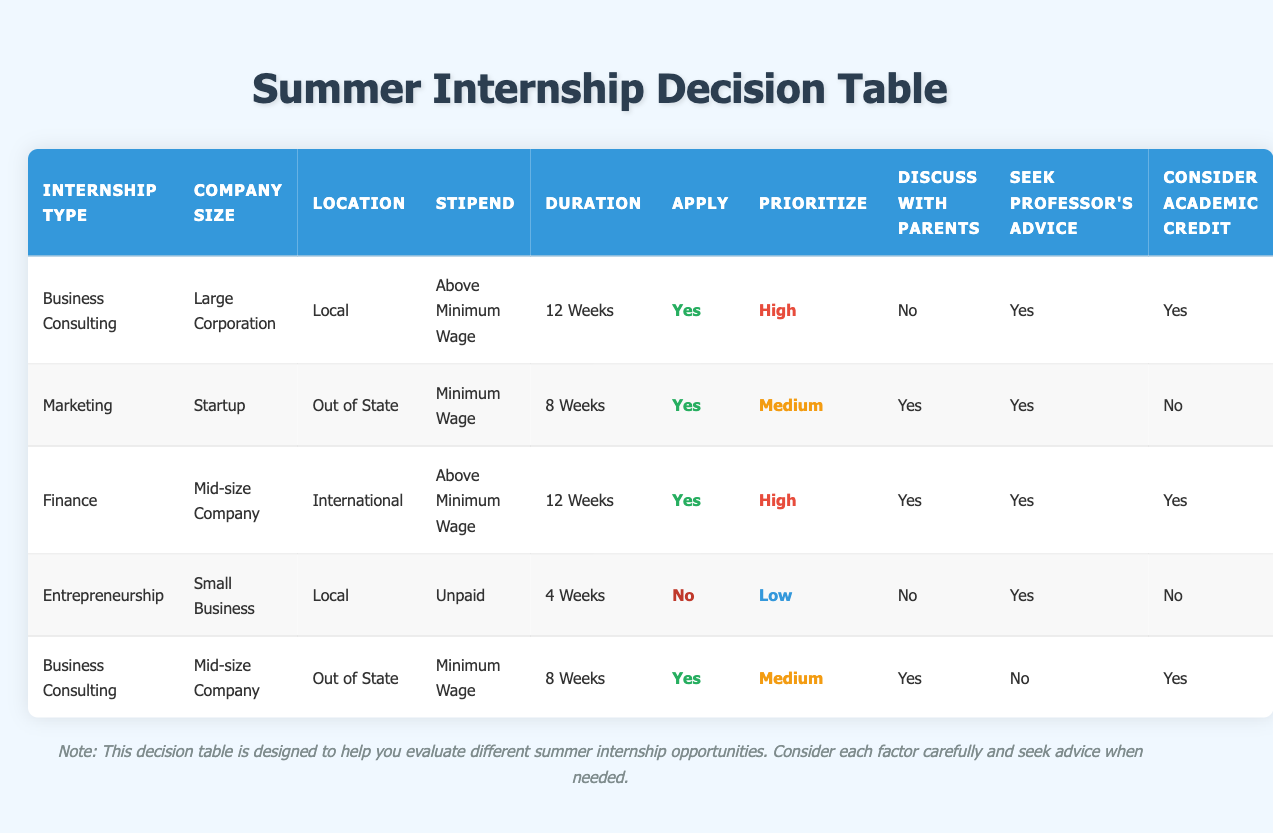What internship type has the highest priority level? The table shows various internship types along with their priority levels. By scanning through the "Prioritize" column, I can identify that both "Business Consulting" at "Large Corporation" and "Finance" at "Mid-size Company" have a priority level of "High." Since "High" is the highest priority, both these internship types qualify.
Answer: Business Consulting, Finance Is there any internship that has an unpaid stipend? Looking at the "Stipend" column, I find that the "Entrepreneurship" internship at "Small Business" has a stipend categorized as "Unpaid." It is confirmed by directly referencing the value in that column.
Answer: Yes How many internships last for 8 weeks? I can count the total number of internships in the "Duration" column that specifically states "8 Weeks." Upon reviewing the table, both the "Marketing" internship and the "Business Consulting" internship (Mid-size Company) last for 8 weeks. This gives a total of two internships.
Answer: 2 For which internship types should I discuss the opportunities with my parents? I need to check the "Discuss with Parents" column for all internship types. By highlighting the options where it says "Yes," I find that the "Marketing," "Finance," and "Business Consulting" (Mid-size Company) internships require discussions with parents. Summarizing this leads to the mentioned internship types.
Answer: Marketing, Finance, Business Consulting (Mid-size Company) What is the average stipend level for internships that apply? To find the average stipend level for internships where "Apply" is "Yes," I first list the stipends from those internships: "Above Minimum Wage," "Minimum Wage," "Above Minimum Wage," and "Minimum Wage." Converting them to numerical values (for instance, 2 for Above Minimum Wage and 1 for Minimum Wage), the calculation becomes (2 + 1 + 2 + 1) = 6. There are four internships that apply, hence the average is 6/4 = 1.5, representing a numeric value between the reported stipend levels.
Answer: 1.5 Which internship has the longest duration and what is its stipend? I must evaluate the "Duration" column for the longest duration entry, which is "12 Weeks." I check each internship's duration and find that both "Business Consulting" (Large Corporation) and "Finance" have this duration. Their corresponding stipends are "Above Minimum Wage" for Business Consulting and "Above Minimum Wage" for Finance, thus confirming that both internships have the same stipend.
Answer: Above Minimum Wage Is there any internship where academic credit is not considered? I scan the "Consider Academic Credit" column and identify which internships have "No" recorded. I see that the internships fitting this requirement are "Marketing" and "Entrepreneurship." Therefore, these internships do not consider academic credit.
Answer: Yes What are the conditions of the internship with the lowest priority? The lowest priority level is termed "Low," and scanning the "Prioritize" column leads me to the "Entrepreneurship" internship at "Small Business." I check other conditions for this internship, and it is unpaid, in a local area, lasts 4 weeks, and runs with no application submission. This sums up all conditions pertinent.
Answer: Entrepreneurship, Small Business, Local, Unpaid, 4 Weeks 